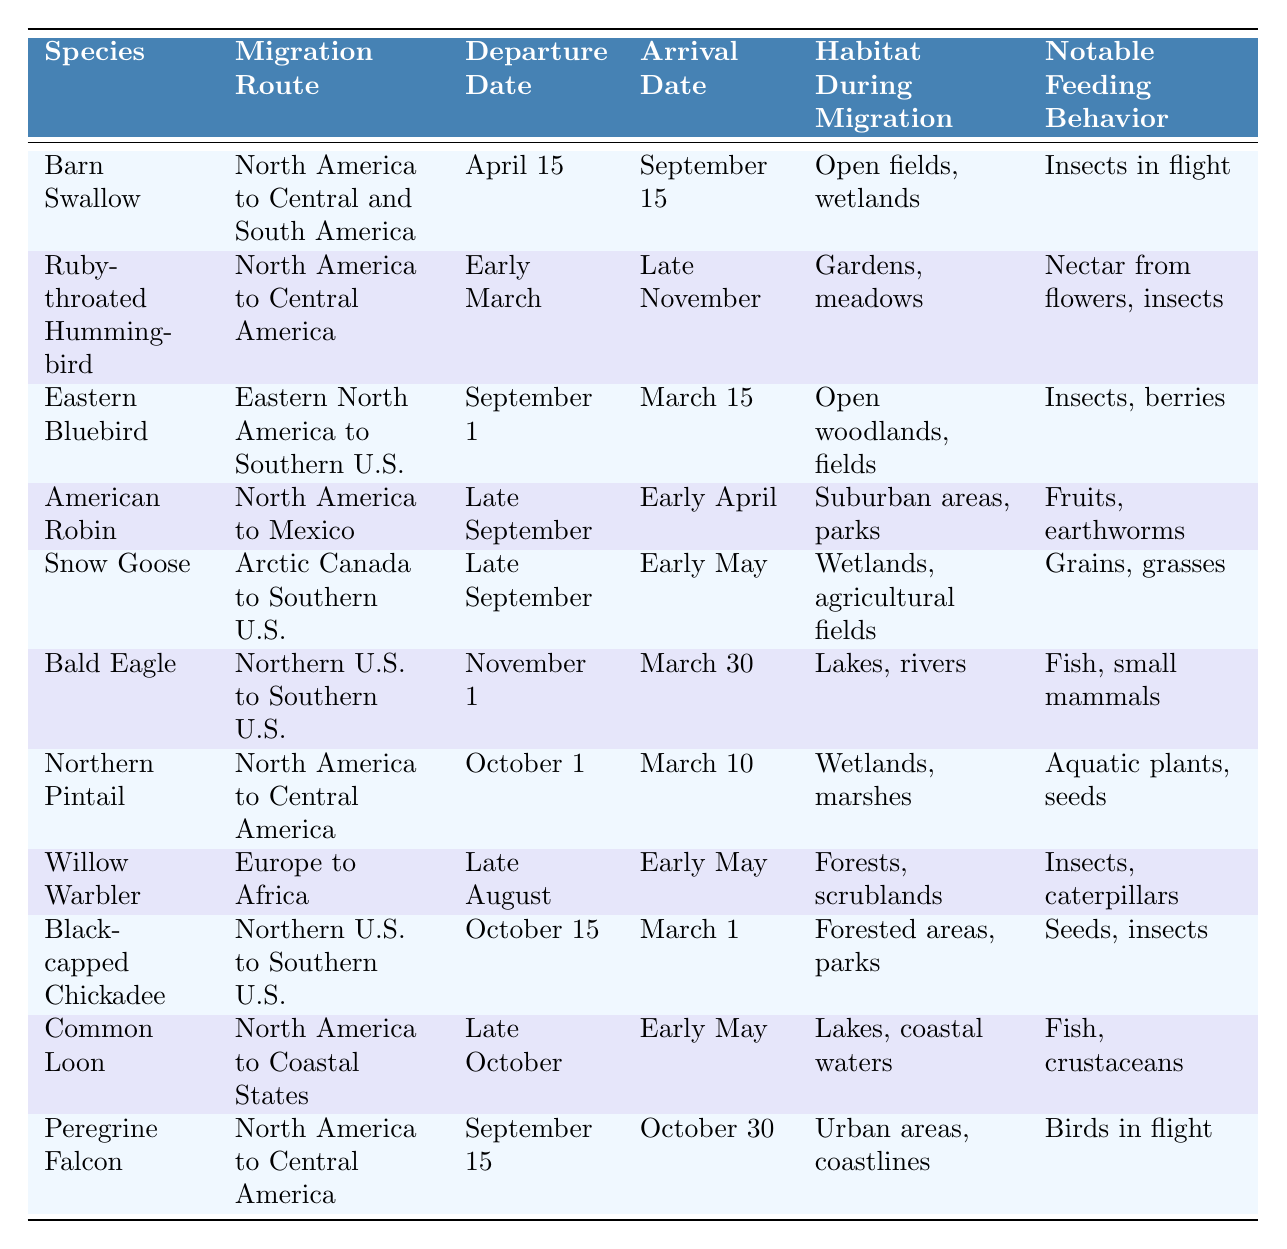What is the migration route of the Bald Eagle? The table lists the migration route for the Bald Eagle as "Northern U.S. to Southern U.S."
Answer: Northern U.S. to Southern U.S When does the Ruby-throated Hummingbird depart? According to the table, the departure date for the Ruby-throated Hummingbird is "Early March."
Answer: Early March Which bird species has the longest migration duration? To find the longest migration duration, compare the departure and arrival dates for each species. The Barn Swallow migrates from April 15 to September 15, which is 5 months, whereas the Eastern Bluebird migrates from September 1 to March 15, which is 6 months. Thus, the Eastern Bluebird has the longest duration.
Answer: Eastern Bluebird Is the Snow Goose's habitat during migration wetlands? The habitat during migration for the Snow Goose is listed as "Wetlands, agricultural fields," which confirms that it includes wetlands.
Answer: Yes How many species migrate to Central America? The table identifies three species migrating to Central America: Ruby-throated Hummingbird, Northern Pintail, and Peregrine Falcon. Therefore, there are three species.
Answer: 3 What is the notable feeding behavior of the Common Loon? The table states that the notable feeding behavior of the Common Loon is "Fish, crustaceans."
Answer: Fish, crustaceans Which bird departs latest and what is their departure date? The table shows that the Bald Eagle departs on November 1, which is later than all other species listed.
Answer: Bald Eagle, November 1 How many species have a departure date in late September? The table shows the American Robin and Snow Goose both have departure dates in late September, totaling two species.
Answer: 2 What is the difference in the arrival dates between the Willow Warbler and the Black-capped Chickadee? The Willow Warbler arrives in early May while the Black-capped Chickadee arrives on March 1. The difference in time is approximately two months.
Answer: Approximately two months Which bird species migrates from Europe, and what is its habitat during migration? The table indicates that the Willow Warbler migrates from Europe to Africa and its habitat during migration is "Forests, scrublands."
Answer: Willow Warbler, Forests, scrublands 